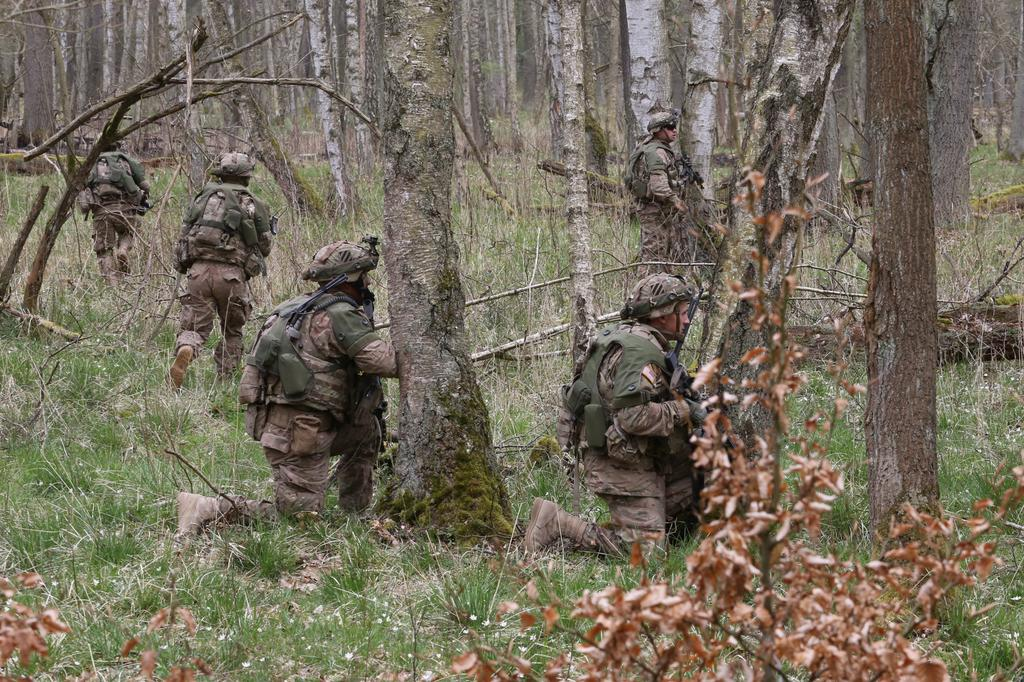What type of clothing are the people wearing in the image? The people are wearing military uniforms in the image. What headgear are the people wearing? The people are wearing helmets in the image. What type of vegetation is present in the image? There are trees in the image. What type of ground cover is visible at the bottom of the image? There is grass at the bottom of the image. Where is the cart located in the image? There is no cart present in the image. What type of cap is being worn by the people in the image? The people are wearing helmets, not caps, in the image. 